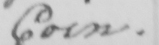What does this handwritten line say? Coin . 